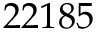<formula> <loc_0><loc_0><loc_500><loc_500>2 2 1 8 5</formula> 